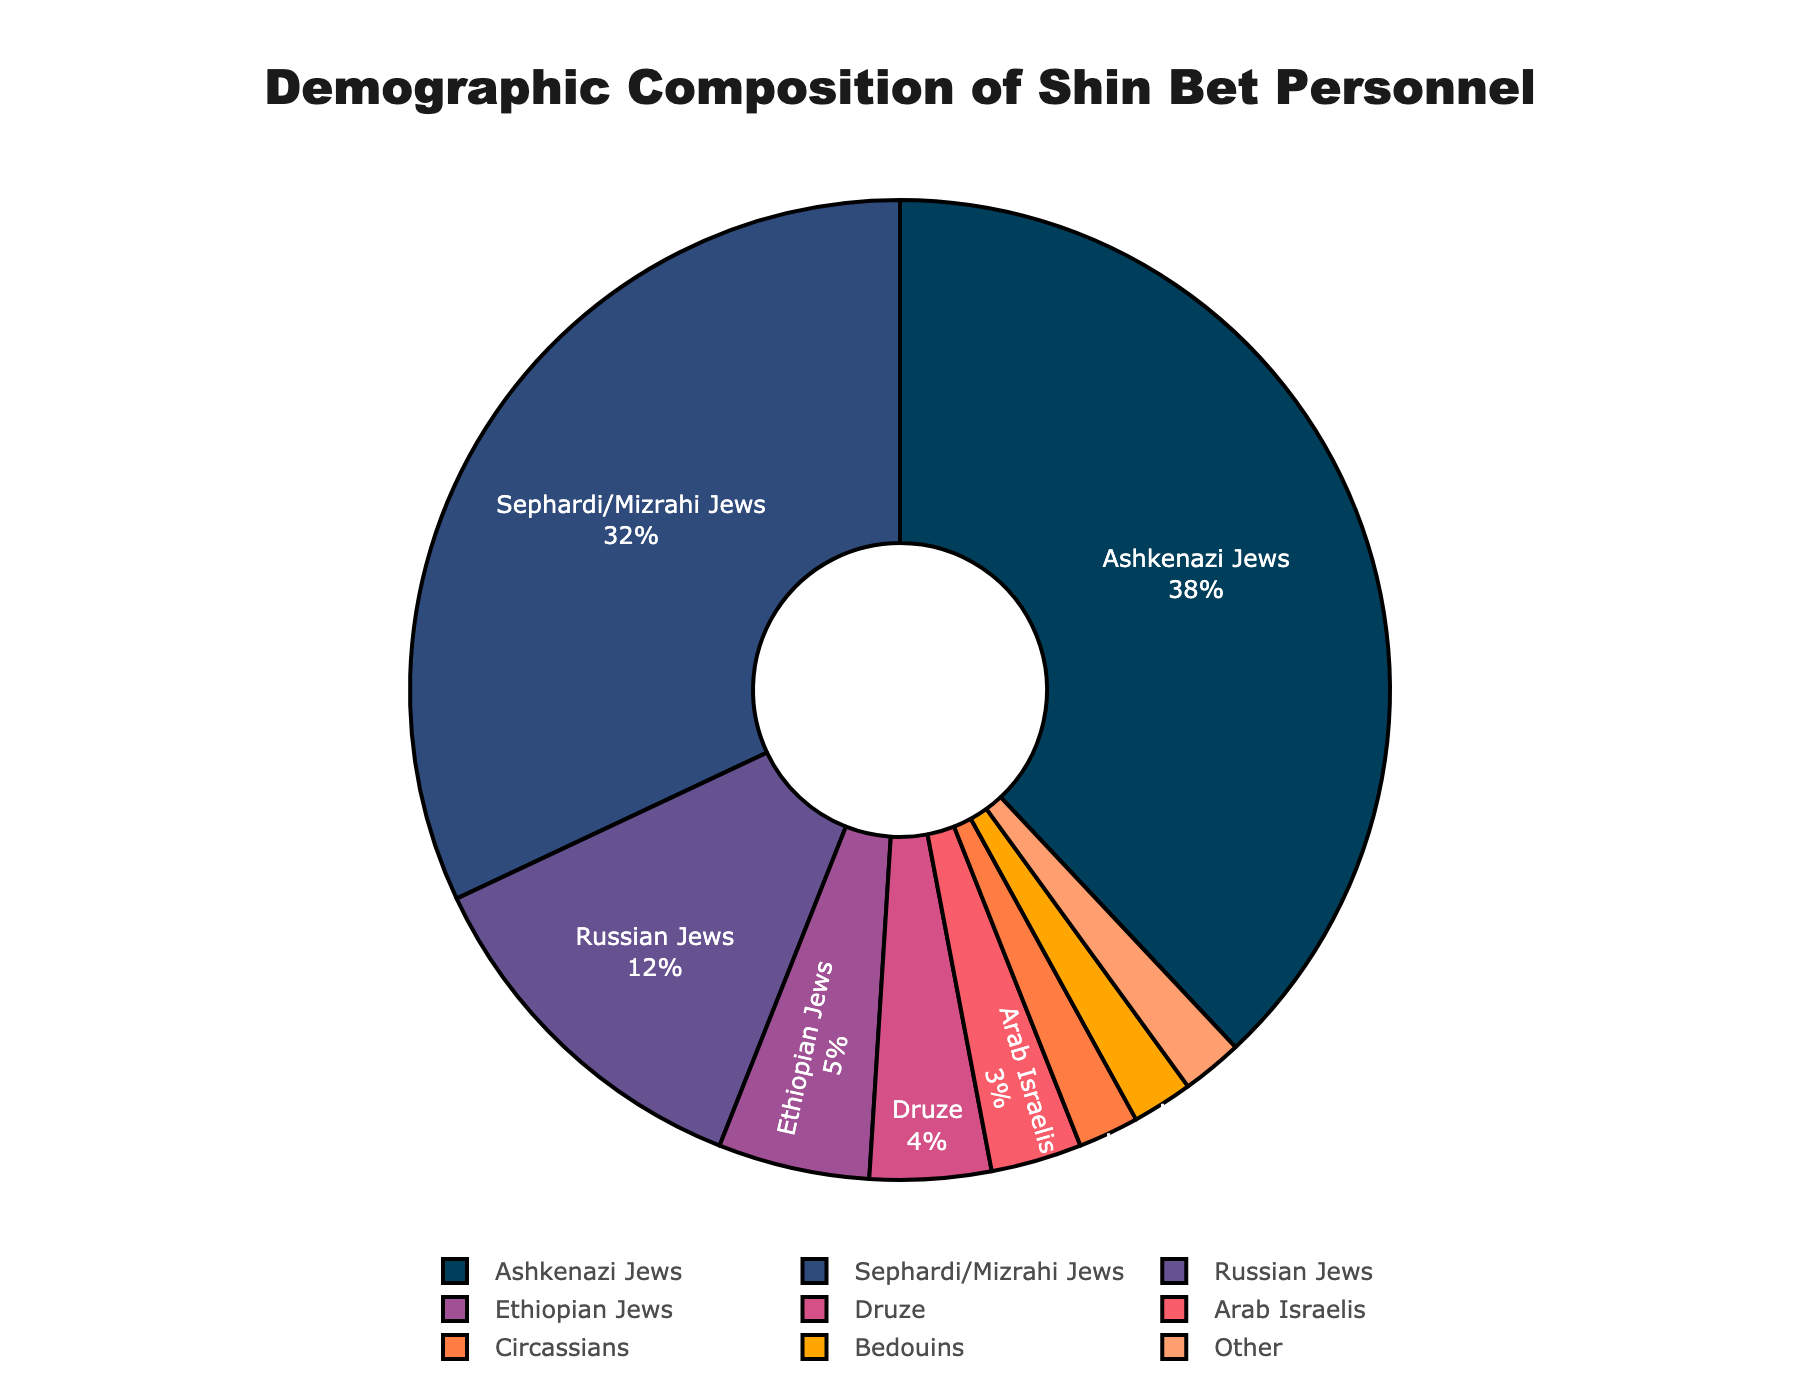What's the percentage of Ashkenazi Jews among Shin Bet personnel? The pie chart explicitly shows the percentage share of each ethnic background. Identify the segment labeled 'Ashkenazi Jews' and read its percentage.
Answer: 38% How much larger is the proportion of Ashkenazi Jews compared to Arab Israelis? Subtract the percentage of Arab Israelis from the percentage of Ashkenazi Jews: 38% - 3% = 35%.
Answer: 35% What is the combined percentage of Sephardi/Mizrahi Jews and Russian Jews? Add the percentages of Sephardi/Mizrahi Jews and Russian Jews: 32% + 12% = 44%.
Answer: 44% Which two ethnic backgrounds, when combined, equal 4%? Identify which percentages add up to 4%. Here, Circassians (2%) and Bedouins (2%) combine to make 4%.
Answer: Circassians and Bedouins Does the percentage of Ethiopian Jews exceed the percentage of Druze personnel? Compare the percentages of Ethiopian Jews (5%) and Druze (4%). Since 5% is greater than 4%, the answer is yes.
Answer: Yes What percentage of Shin Bet personnel comes from the smallest represented groups? Identify the groups with the smallest percentage. Add up the percentages of Circassians (2%), Bedouins (2%), and Other (2%): 2% + 2% + 2% = 6%.
Answer: 6% Which ethnic group is represented by the color closest to red? Visually identify the segment in the chart that is colored closest to red, which corresponds to Ethiopian Jews.
Answer: Ethiopian Jews What is the difference between the percentage of Ashkenazi Jews and Druze personnel? Subtract the percentage of Druze from Ashkenazi Jews: 38% - 4% = 34%.
Answer: 34% Which ethnic backgrounds have a combined percentage that is less than 10% but more than 5%? Add combinations of smaller percentages and check if they fall within the specified range. Arab Israelis (3%) + Circassians (2%) = 5%, adding Bedouins (2%) makes 7%.
Answer: Arab Israelis, Circassians, Bedouins Who has a larger representation, Russian Jews or the combined group of Circassians and Bedouins? Compare the percentage of Russian Jews (12%) with the sum of Circassians and Bedouins: 2% + 2% = 4%. Since 12% > 4%, Russian Jews have a larger representation.
Answer: Russian Jews 